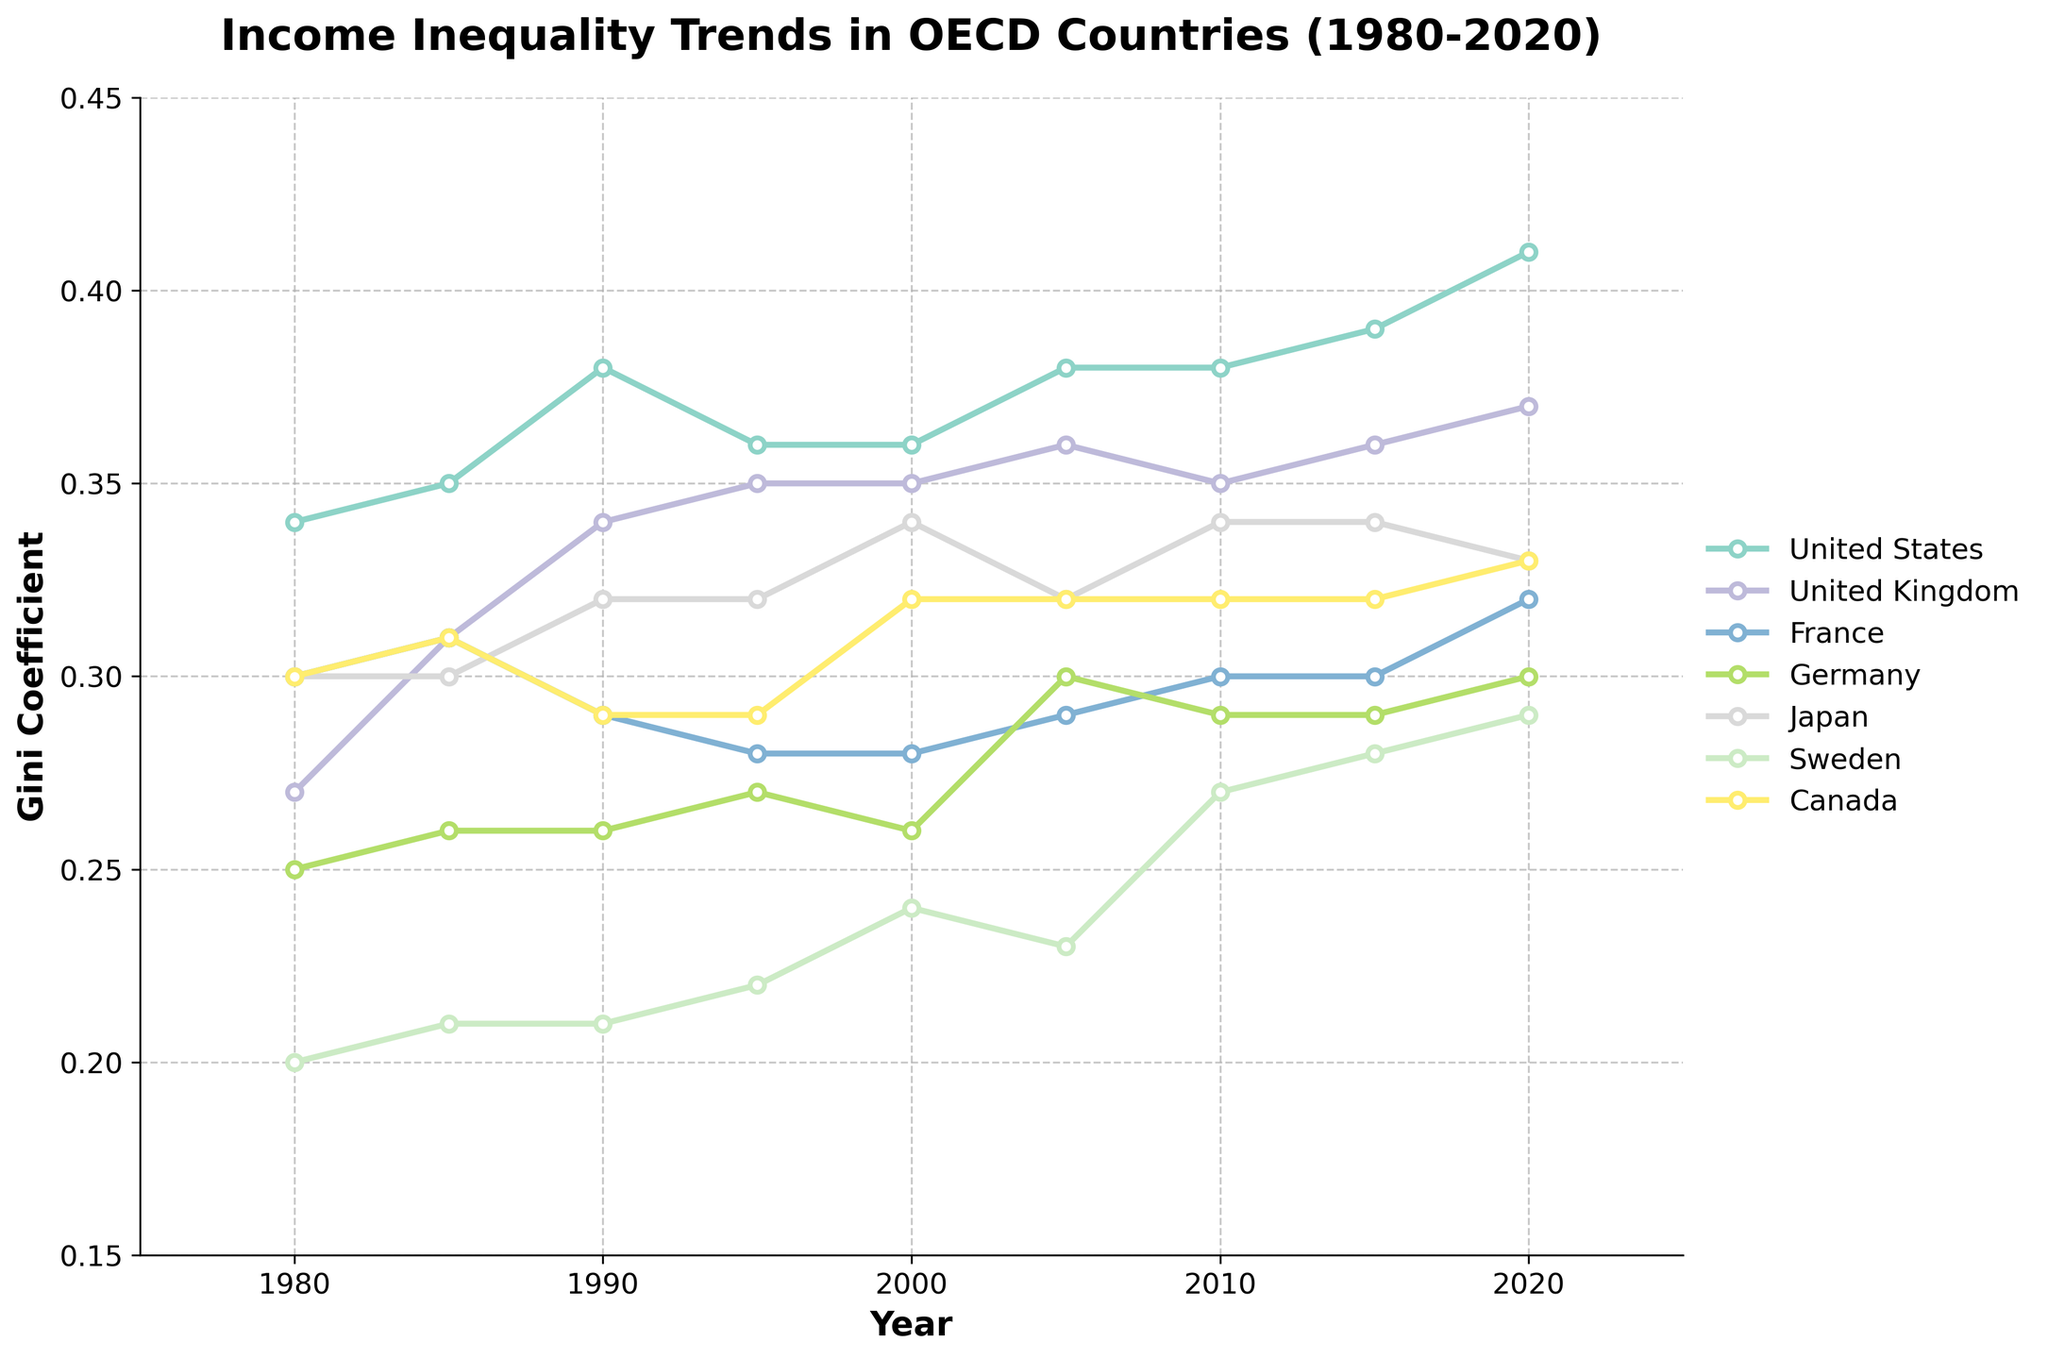What is the Gini coefficient for the United States in 2020? Locate the point for the United States on the graph at the year 2020. The Y-axis value corresponding to this point is approximately 0.41.
Answer: 0.41 Which country had the lowest Gini coefficient in 1980? Identify the points on the graph for 1980 and compare their Y-axis values. The country with the lowest Y-axis value is Sweden, with a Gini coefficient of 0.20.
Answer: Sweden How did income inequality in Japan change from 1980 to 2020? Trace the line for Japan from 1980 to 2020. In 1980, the Gini coefficient was 0.30, and it increased to 0.33 by 2020. This shows an overall increase in income inequality.
Answer: Increased Over the period from 1980 to 2020, which country exhibited the largest increase in the Gini coefficient? Examine the lines for all countries from 1980 to 2020 and calculate the differences between the values in these years. The United States shows the largest increase from 0.34 to 0.41, an increase of 0.07.
Answer: United States Which countries had a Gini coefficient of 0.30 or higher throughout the study period? Identify the lines that remain at or above the 0.30 mark on the Y-axis from 1980 to 2020. The United States and Japan consistently had values of 0.30 or higher.
Answer: United States, Japan What is the average Gini coefficient of Germany for the years 1980, 1990, and 2000? Locate the points for Germany in 1980 (0.25), 1990 (0.26), and 2000 (0.26). Add these values and divide by 3: (0.25 + 0.26 + 0.26) / 3 = 0.2567.
Answer: 0.2567 In which year did the United Kingdom have its highest Gini coefficient? Track the United Kingdom's line and identify the peak value. The highest Gini coefficient is approximately 0.37, occurring in 2020.
Answer: 2020 Between 1985 and 2000, which country showed the most significant decrease in its Gini coefficient? Examine the changes in the Gini coefficients for all countries between 1985 and 2000. France showed a decrease from 0.31 to 0.28, a reduction of 0.03, which is the largest.
Answer: France 